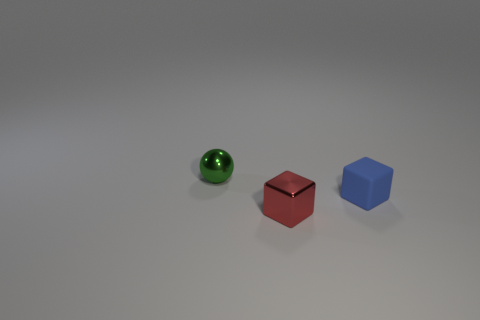What size is the green object that is made of the same material as the tiny red block?
Make the answer very short. Small. What material is the small object that is behind the tiny cube behind the small metallic object in front of the tiny blue block?
Ensure brevity in your answer.  Metal. Is the number of balls less than the number of tiny yellow cylinders?
Your response must be concise. No. Does the small red cube have the same material as the small green object?
Keep it short and to the point. Yes. Does the small shiny object in front of the green thing have the same color as the small rubber cube?
Give a very brief answer. No. How many tiny things are in front of the block on the right side of the tiny red metallic thing?
Ensure brevity in your answer.  1. The cube that is the same size as the blue matte thing is what color?
Make the answer very short. Red. What is the tiny cube that is in front of the small blue matte cube made of?
Your response must be concise. Metal. What is the material of the tiny object that is right of the green shiny ball and behind the tiny metallic block?
Your answer should be very brief. Rubber. There is a object in front of the blue rubber thing; is its size the same as the small green shiny sphere?
Provide a succinct answer. Yes. 